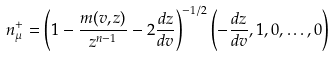Convert formula to latex. <formula><loc_0><loc_0><loc_500><loc_500>n _ { \mu } ^ { + } = \left ( 1 - \frac { m ( v , z ) } { z ^ { n - 1 } } - 2 \frac { d z } { d v } \right ) ^ { - 1 / 2 } \left ( - \frac { d z } { d v } , 1 , 0 , \dots , 0 \right )</formula> 